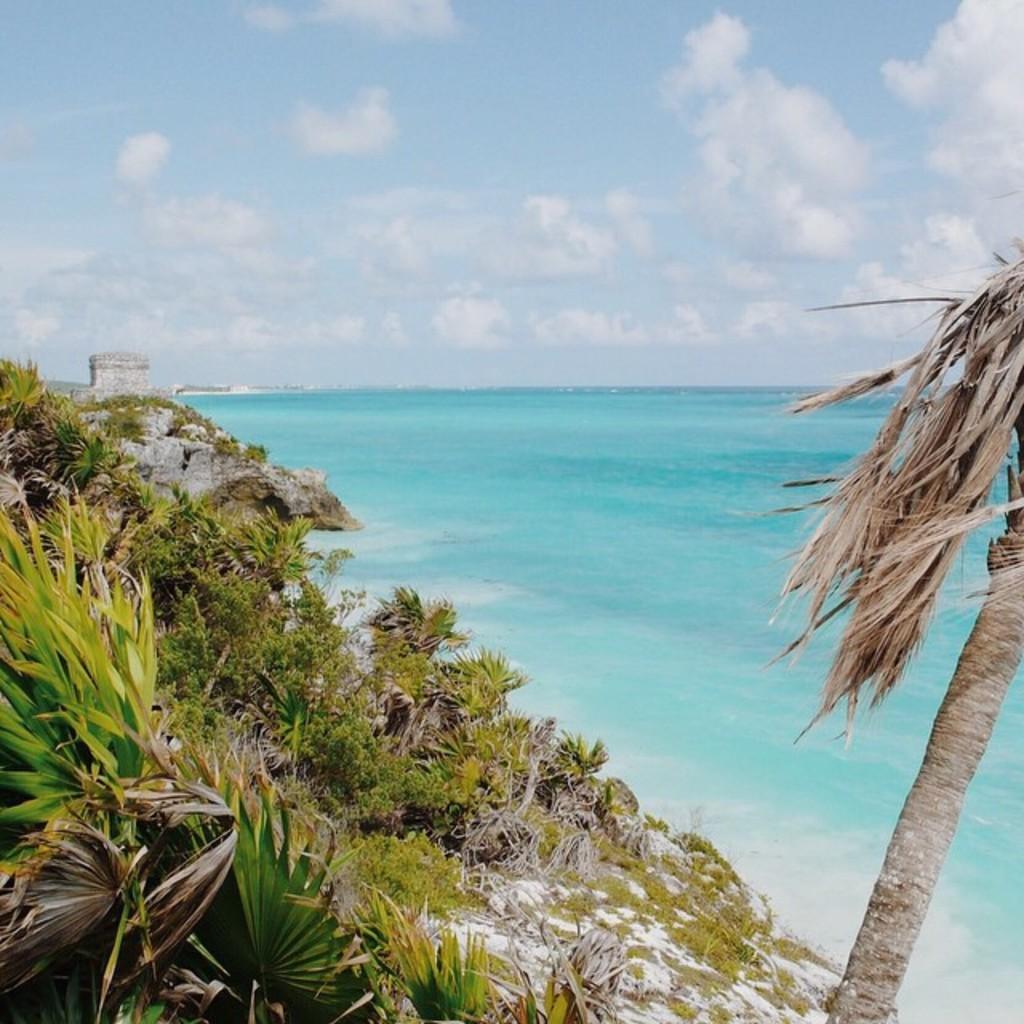Can you describe this image briefly? This picture is taken on the sea shore. Towards the left there is a hill with plants and trees. Towards the right, there is a tree. In the center, there is an ocean. On the top, there is a sky with clouds. 